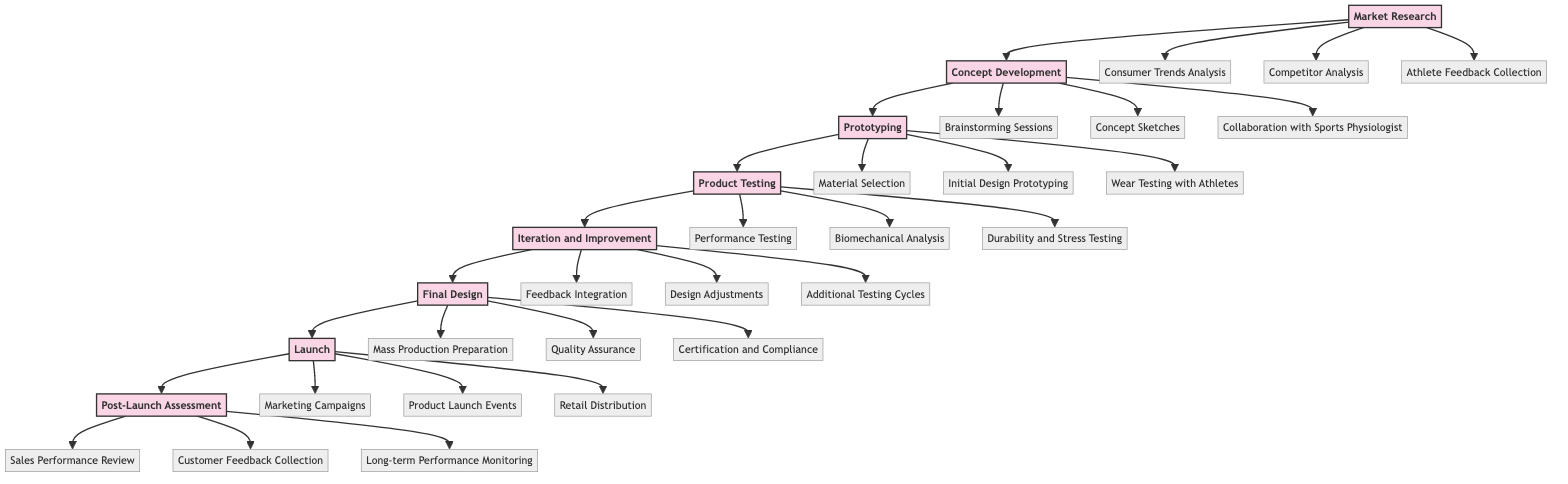What is the first phase of the product development lifecycle? The first phase is represented as "Market Research" in the diagram, which is the first node in the flow.
Answer: Market Research How many elements are included in the "Product Testing" phase? The "Product Testing" phase includes three elements: Performance Testing, Biomechanical Analysis, and Durability and Stress Testing, as indicated by the connections to the node.
Answer: 3 What is the last phase before the "Launch" phase? The last phase before "Launch" is "Final Design" as shown by the direct connection from "Final Design" to "Launch."
Answer: Final Design Which phase involves collaboration with a sports physiologist? The phase that involves collaboration with a sports physiologist is "Concept Development," where one of the elements listed is specifically labeled as such.
Answer: Concept Development What are the three elements in the "Iteration and Improvement" phase? The three elements in "Iteration and Improvement" are Feedback Integration, Design Adjustments, and Additional Testing Cycles, which are directly linked to the "Iteration and Improvement" node in the diagram.
Answer: Feedback Integration, Design Adjustments, Additional Testing Cycles Which phase follows "Prototyping"? According to the flow of the diagram, the phase that follows "Prototyping" is "Product Testing," as indicated by the arrow leading from "Prototyping" to "Product Testing."
Answer: Product Testing How many total phases are represented in the product development lifecycle? The diagram contains a total of eight phases, which are listed sequentially in the flow from "Market Research" to "Post-Launch Assessment."
Answer: 8 What is the final stage of the product development lifecycle? The final stage is represented as "Post-Launch Assessment" in the diagram, which is the last node connected in the flow.
Answer: Post-Launch Assessment Which phase includes "Retail Distribution" as an element? "Launch" includes "Retail Distribution" as one of its elements, as shown by the list stemming from the "Launch" node.
Answer: Launch 